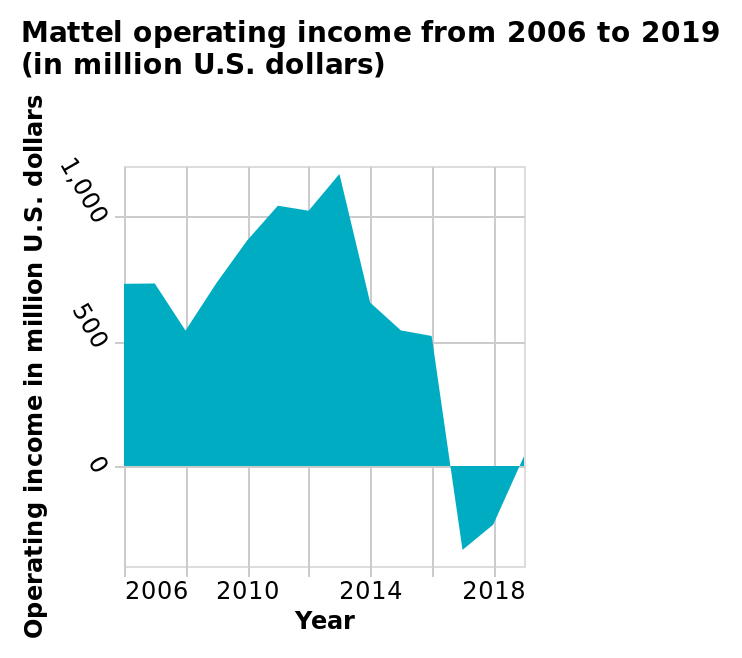<image>
What does the speaker suspect about the future based on the chart?  The speaker suspects that things will improve in the future based on the upward turn shown in the chart. What was the best year mentioned in the figure?  The best year mentioned in the figure is 2013. 